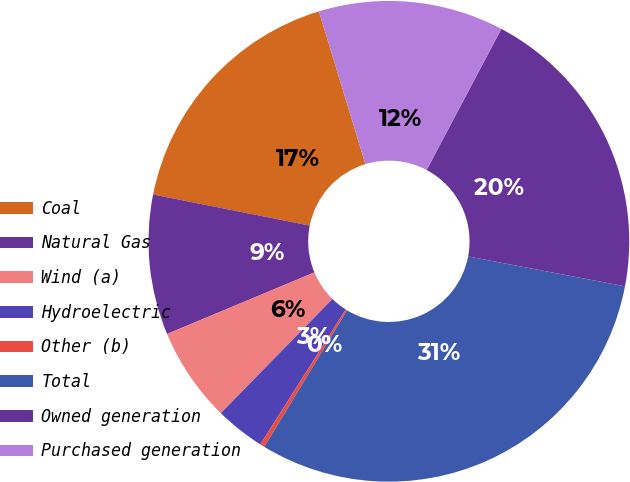Convert chart. <chart><loc_0><loc_0><loc_500><loc_500><pie_chart><fcel>Coal<fcel>Natural Gas<fcel>Wind (a)<fcel>Hydroelectric<fcel>Other (b)<fcel>Total<fcel>Owned generation<fcel>Purchased generation<nl><fcel>17.18%<fcel>9.42%<fcel>6.38%<fcel>3.34%<fcel>0.31%<fcel>30.67%<fcel>20.25%<fcel>12.45%<nl></chart> 